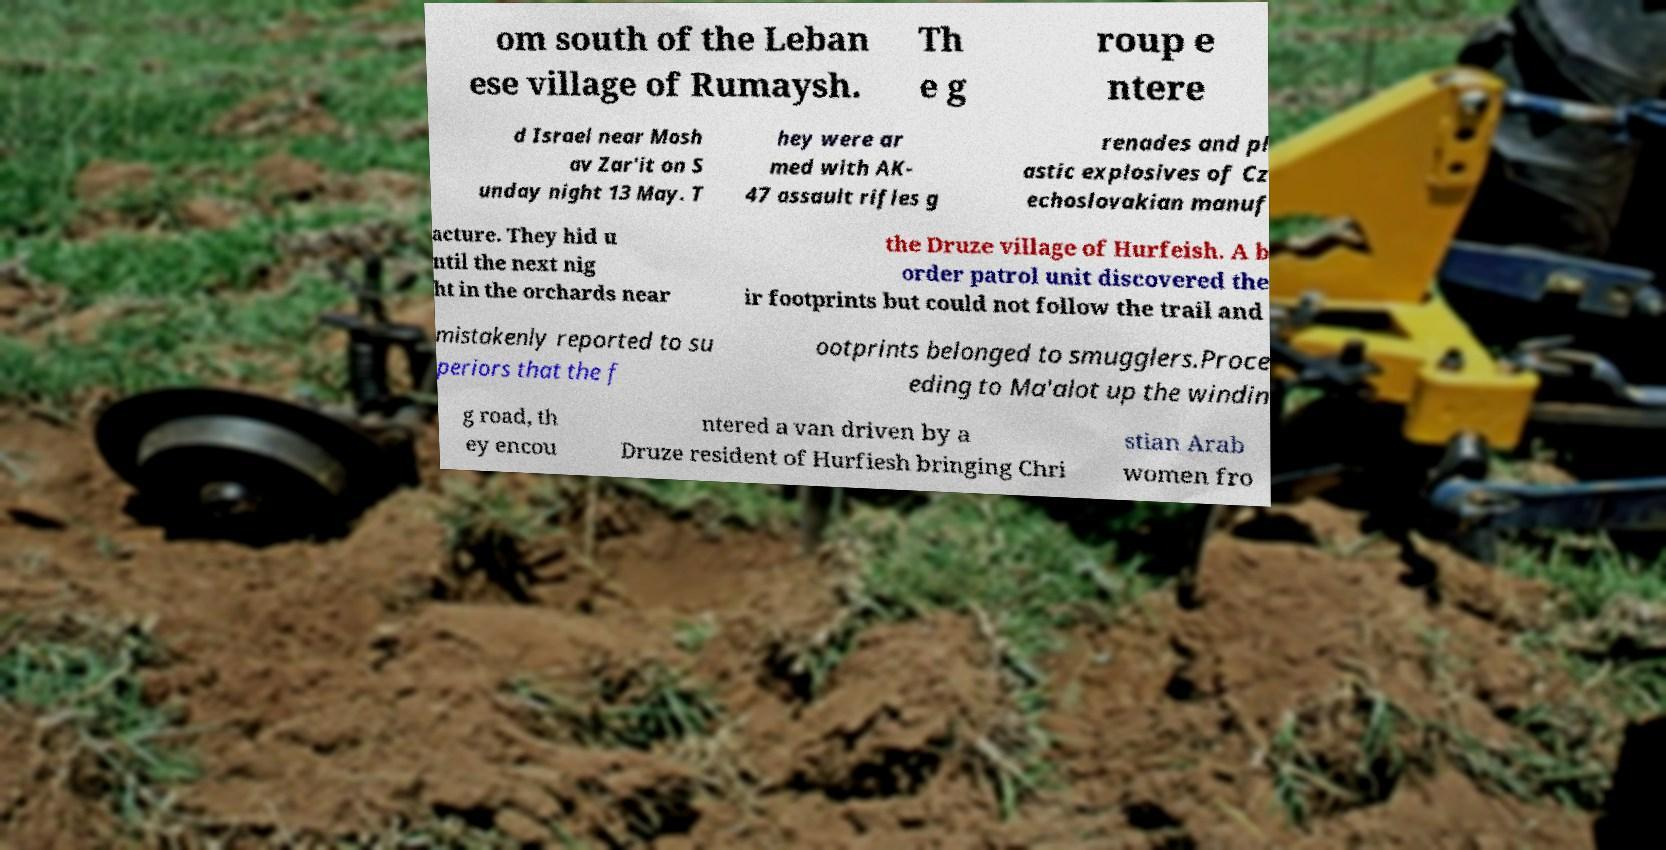What messages or text are displayed in this image? I need them in a readable, typed format. om south of the Leban ese village of Rumaysh. Th e g roup e ntere d Israel near Mosh av Zar'it on S unday night 13 May. T hey were ar med with AK- 47 assault rifles g renades and pl astic explosives of Cz echoslovakian manuf acture. They hid u ntil the next nig ht in the orchards near the Druze village of Hurfeish. A b order patrol unit discovered the ir footprints but could not follow the trail and mistakenly reported to su periors that the f ootprints belonged to smugglers.Proce eding to Ma'alot up the windin g road, th ey encou ntered a van driven by a Druze resident of Hurfiesh bringing Chri stian Arab women fro 